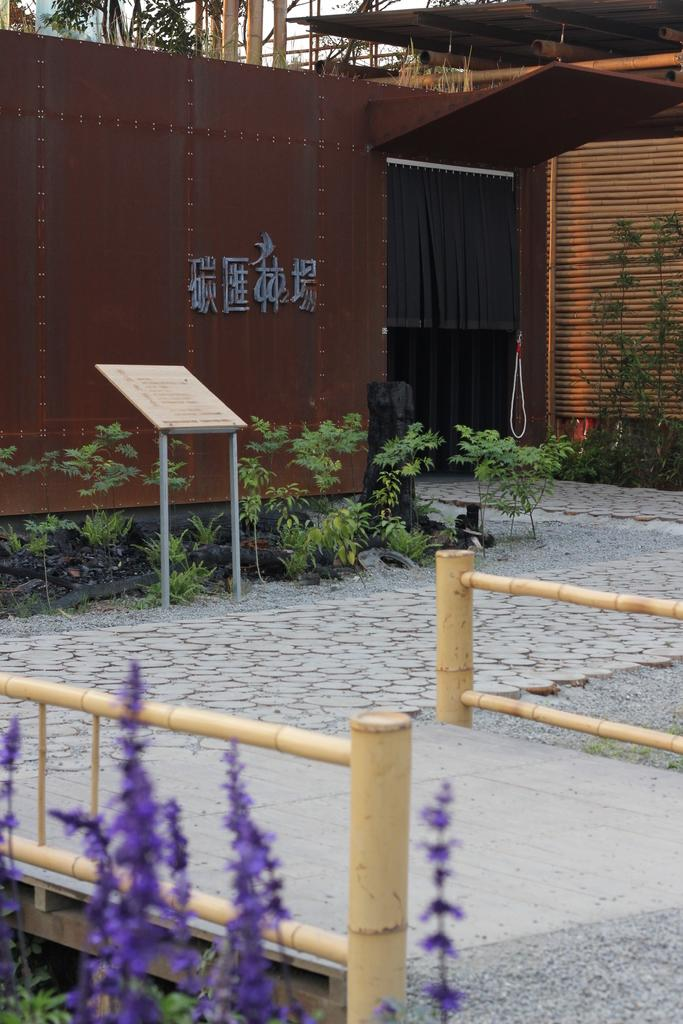What is the predominant color shade in the image? The image has a brown color shade. What type of natural elements can be seen in the image? There are plants in the image. What is the flat, rectangular object in the image? There is a board in the image. What type of barrier is present in the image? There is a fencing in the image. What type of path is visible in the image? There is a footpath in the image. How many boats are visible in the image? There are no boats present in the image. What type of marble is used for the board in the image? There is no marble used for the board in the image; it is not mentioned in the facts provided. 